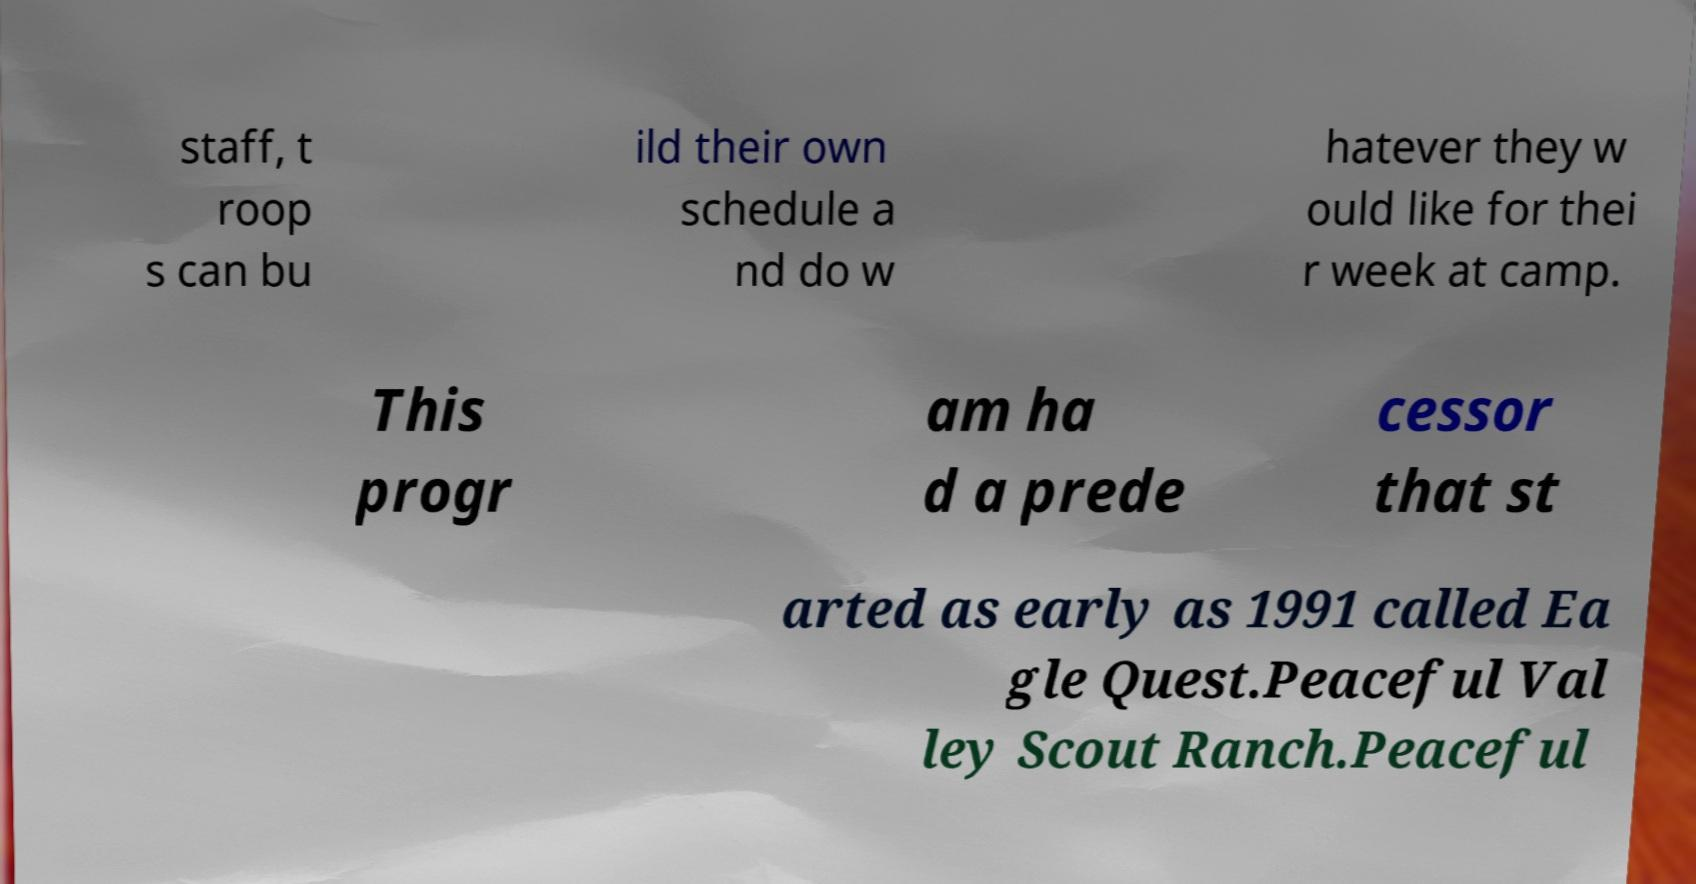Could you assist in decoding the text presented in this image and type it out clearly? staff, t roop s can bu ild their own schedule a nd do w hatever they w ould like for thei r week at camp. This progr am ha d a prede cessor that st arted as early as 1991 called Ea gle Quest.Peaceful Val ley Scout Ranch.Peaceful 